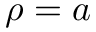<formula> <loc_0><loc_0><loc_500><loc_500>\rho = a</formula> 